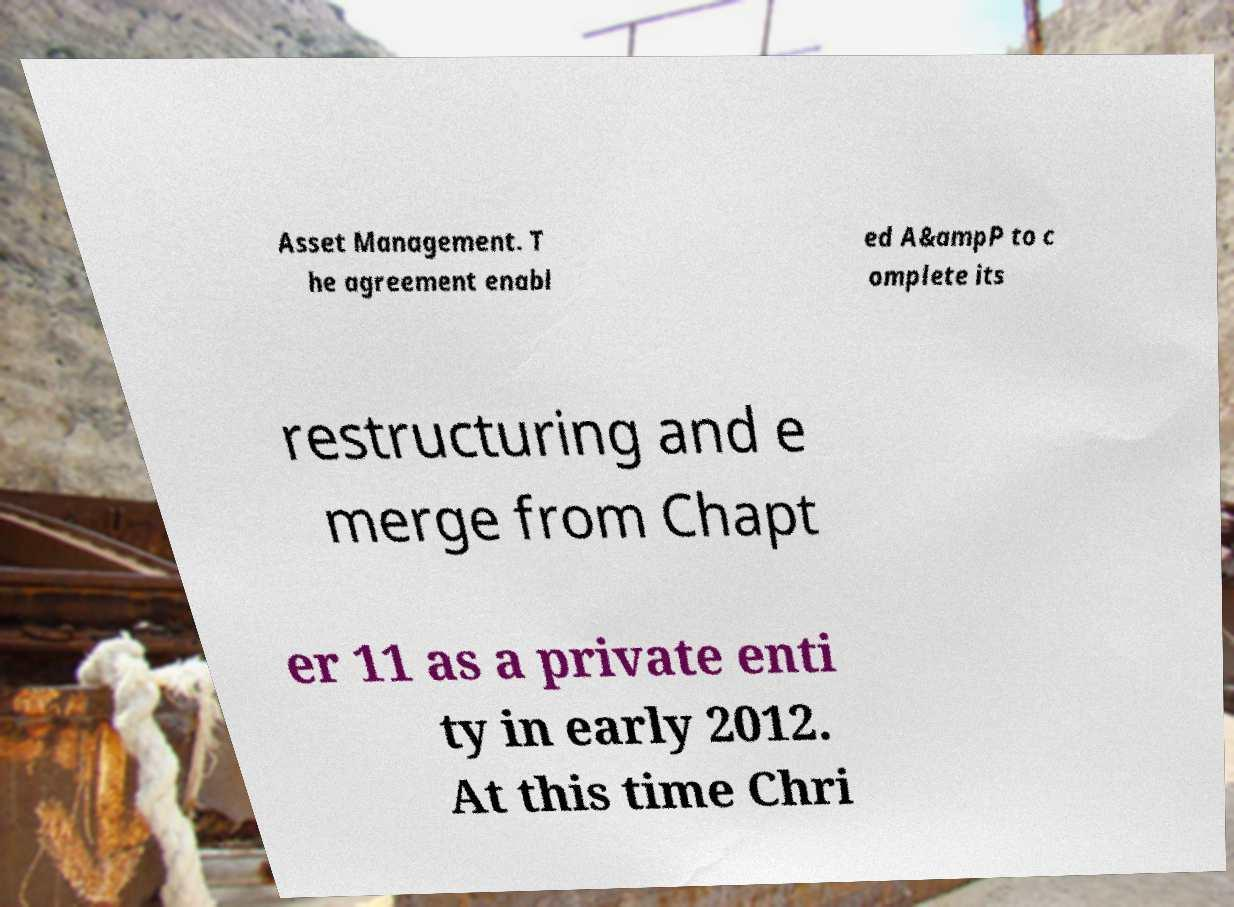I need the written content from this picture converted into text. Can you do that? Asset Management. T he agreement enabl ed A&ampP to c omplete its restructuring and e merge from Chapt er 11 as a private enti ty in early 2012. At this time Chri 